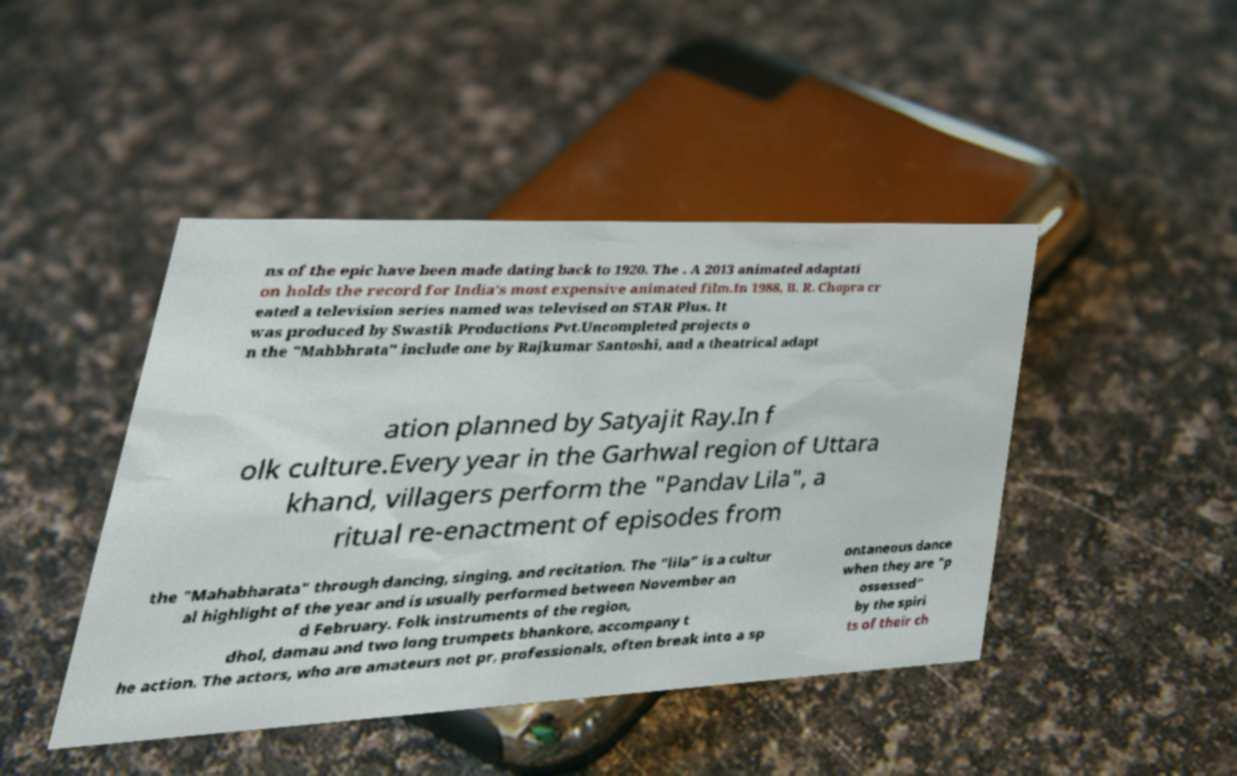I need the written content from this picture converted into text. Can you do that? ns of the epic have been made dating back to 1920. The . A 2013 animated adaptati on holds the record for India's most expensive animated film.In 1988, B. R. Chopra cr eated a television series named was televised on STAR Plus. It was produced by Swastik Productions Pvt.Uncompleted projects o n the "Mahbhrata" include one by Rajkumar Santoshi, and a theatrical adapt ation planned by Satyajit Ray.In f olk culture.Every year in the Garhwal region of Uttara khand, villagers perform the "Pandav Lila", a ritual re-enactment of episodes from the "Mahabharata" through dancing, singing, and recitation. The "lila" is a cultur al highlight of the year and is usually performed between November an d February. Folk instruments of the region, dhol, damau and two long trumpets bhankore, accompany t he action. The actors, who are amateurs not pr, professionals, often break into a sp ontaneous dance when they are "p ossessed" by the spiri ts of their ch 